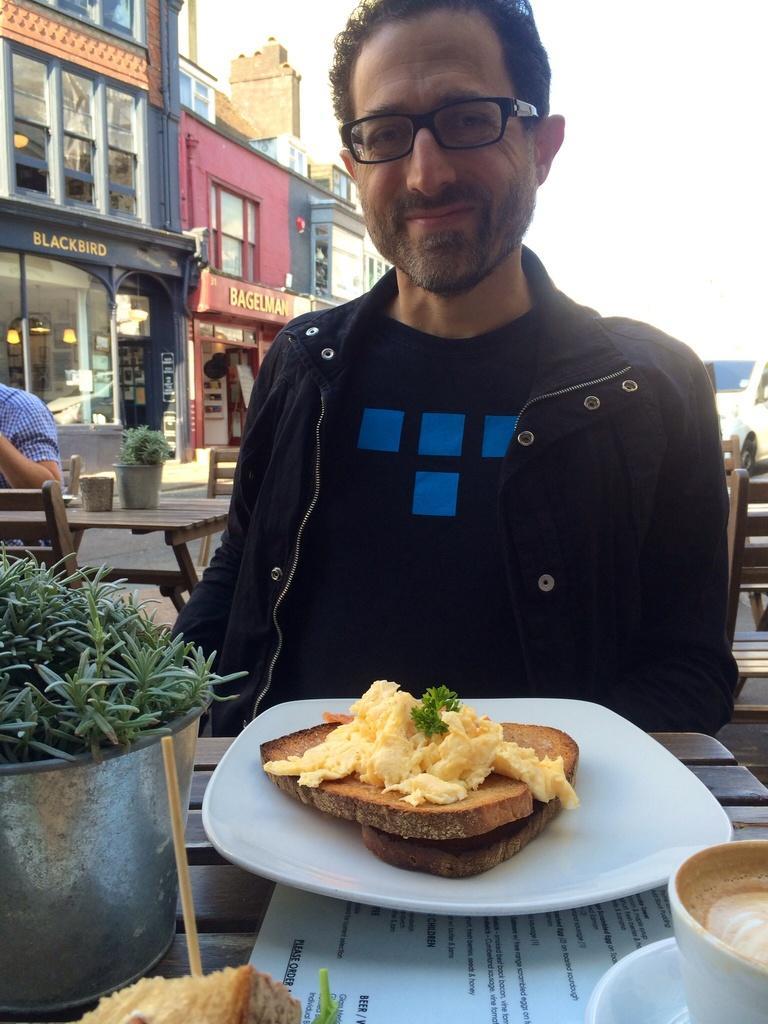Could you give a brief overview of what you see in this image? This image consists of a man wearing a black jacket. In front of him, there is a table on which there are sandwiches, coffee and a plant kept. In the background, there are buildings. 